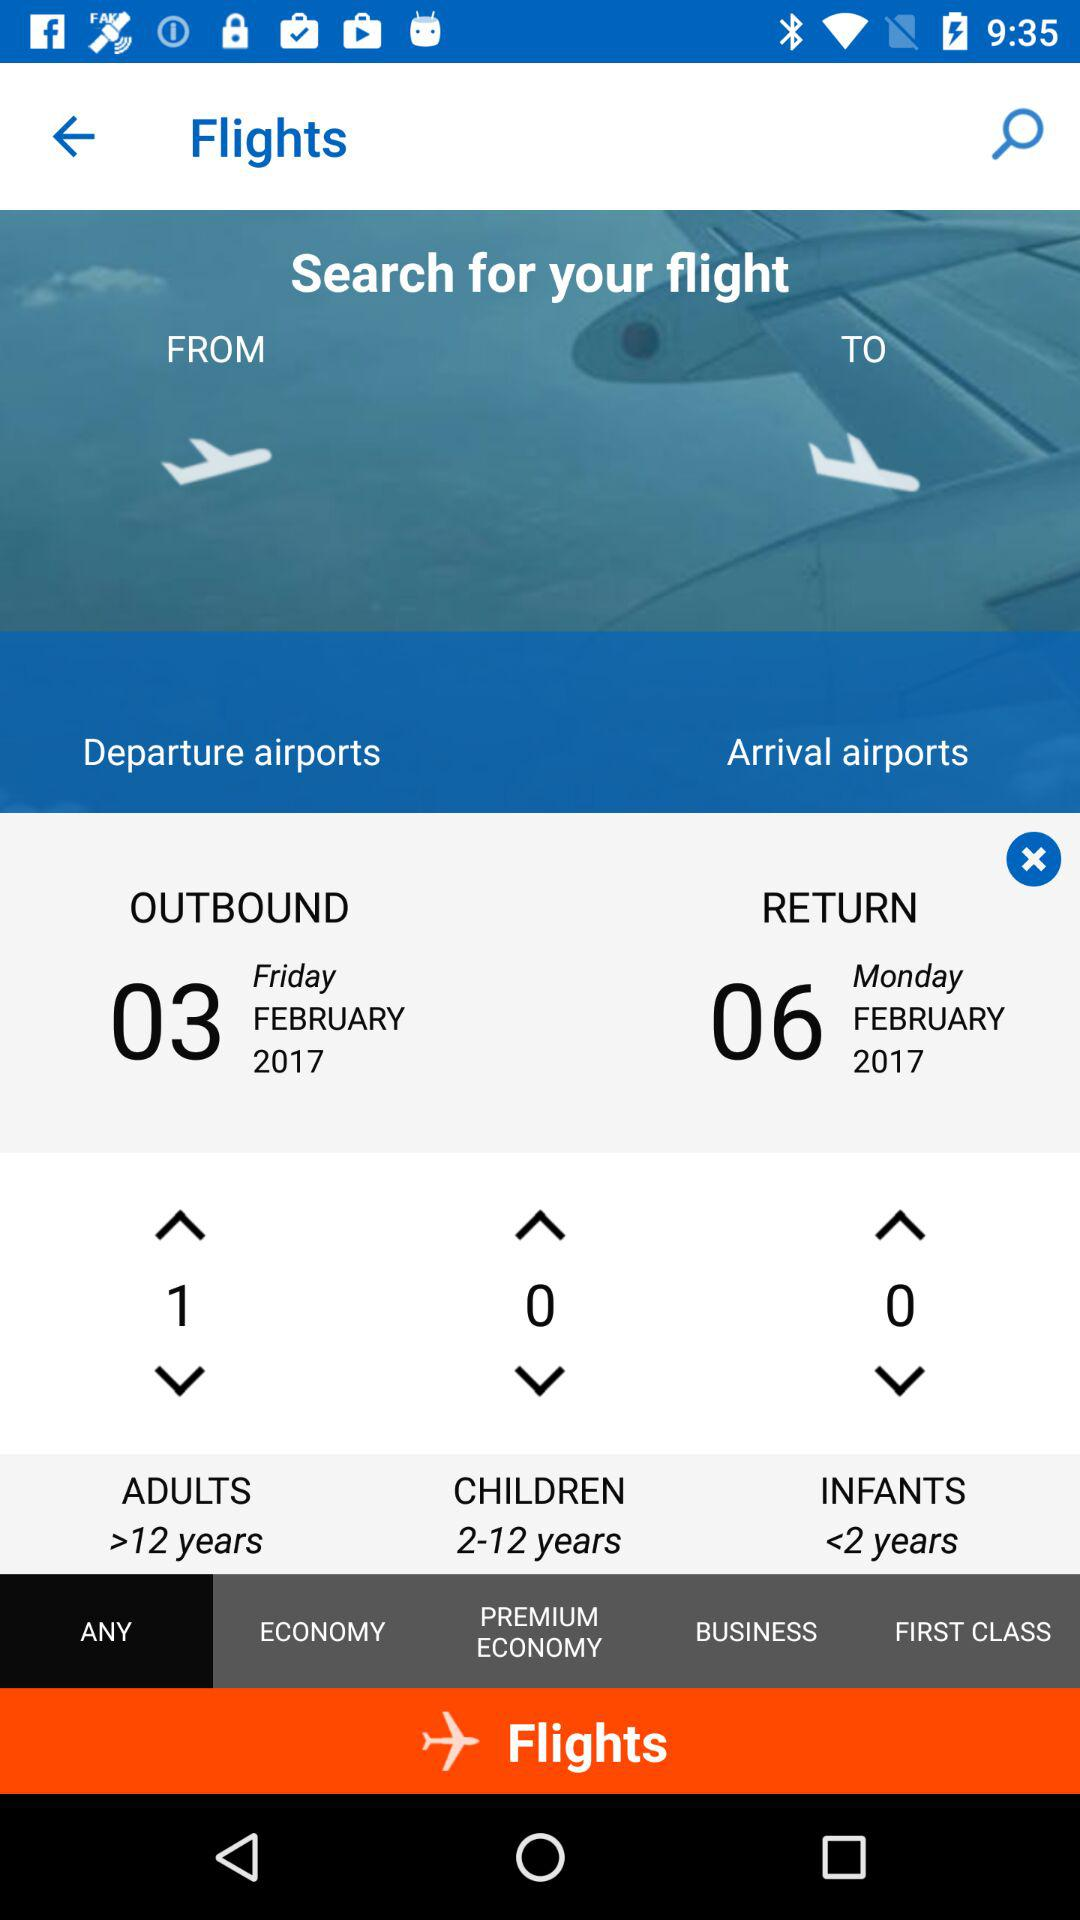What is the outbound date? The outbound date is Friday, February 3, 2017. 